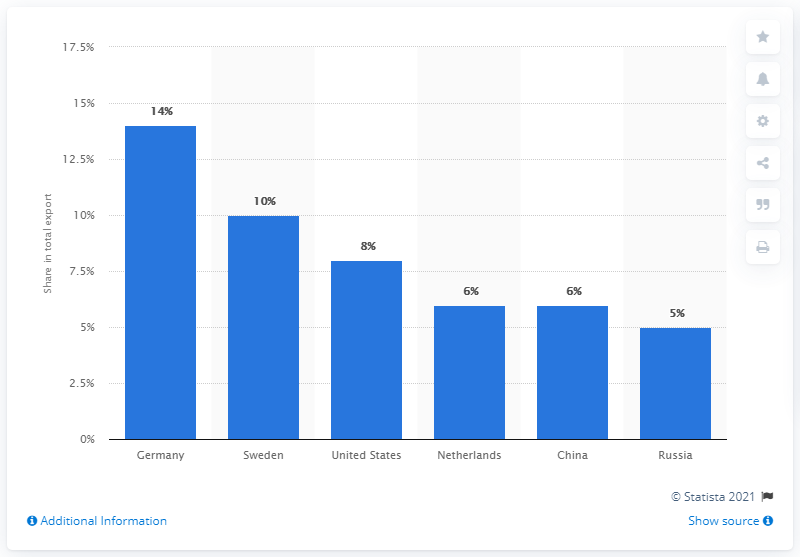Draw attention to some important aspects in this diagram. In 2019, Germany was Finland's most important export partner, accounting for a significant portion of Finland's total exports. 